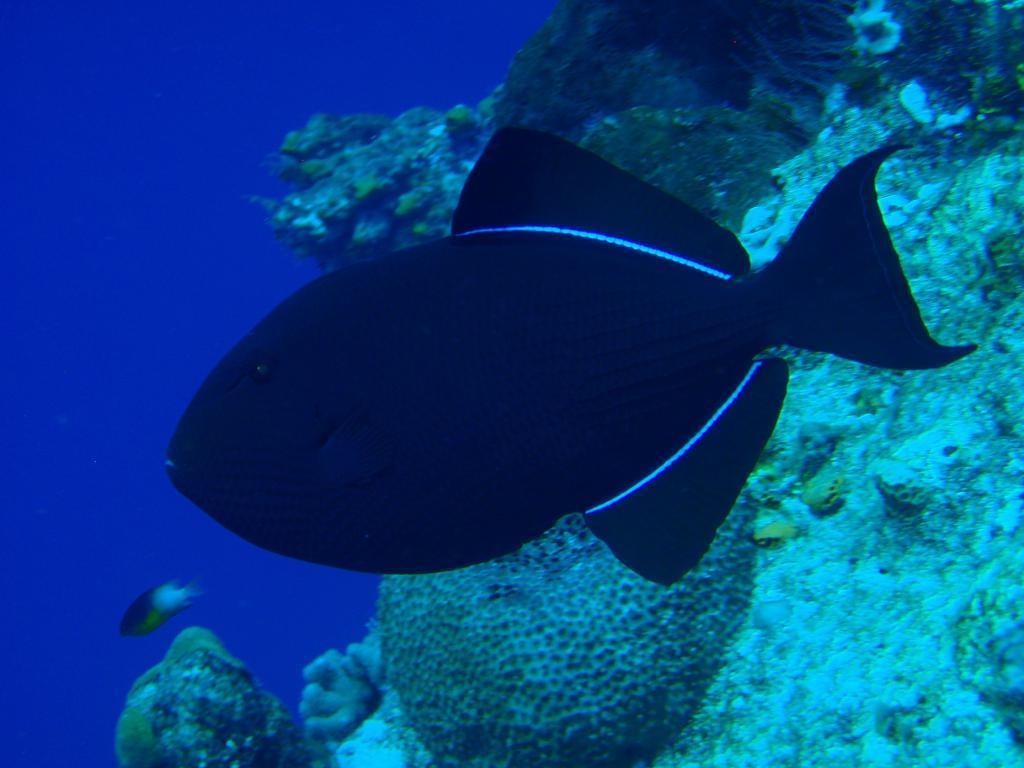Can you describe this image briefly? In the foreground of this image, there are fish in the water. On the right background, it seems like a water plant. 